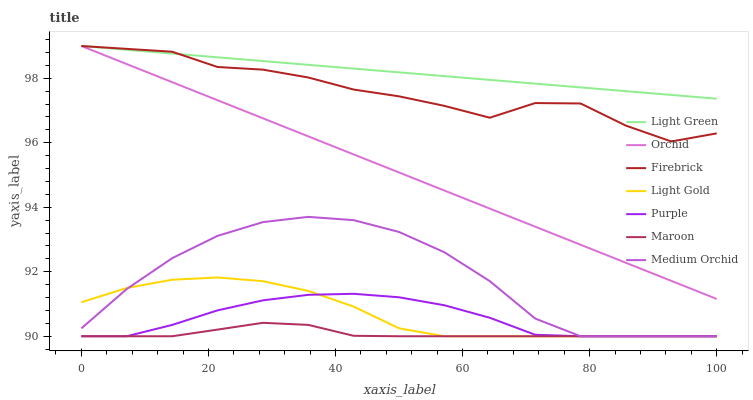Does Maroon have the minimum area under the curve?
Answer yes or no. Yes. Does Light Green have the maximum area under the curve?
Answer yes or no. Yes. Does Firebrick have the minimum area under the curve?
Answer yes or no. No. Does Firebrick have the maximum area under the curve?
Answer yes or no. No. Is Orchid the smoothest?
Answer yes or no. Yes. Is Firebrick the roughest?
Answer yes or no. Yes. Is Medium Orchid the smoothest?
Answer yes or no. No. Is Medium Orchid the roughest?
Answer yes or no. No. Does Firebrick have the lowest value?
Answer yes or no. No. Does Medium Orchid have the highest value?
Answer yes or no. No. Is Light Gold less than Firebrick?
Answer yes or no. Yes. Is Firebrick greater than Medium Orchid?
Answer yes or no. Yes. Does Light Gold intersect Firebrick?
Answer yes or no. No. 